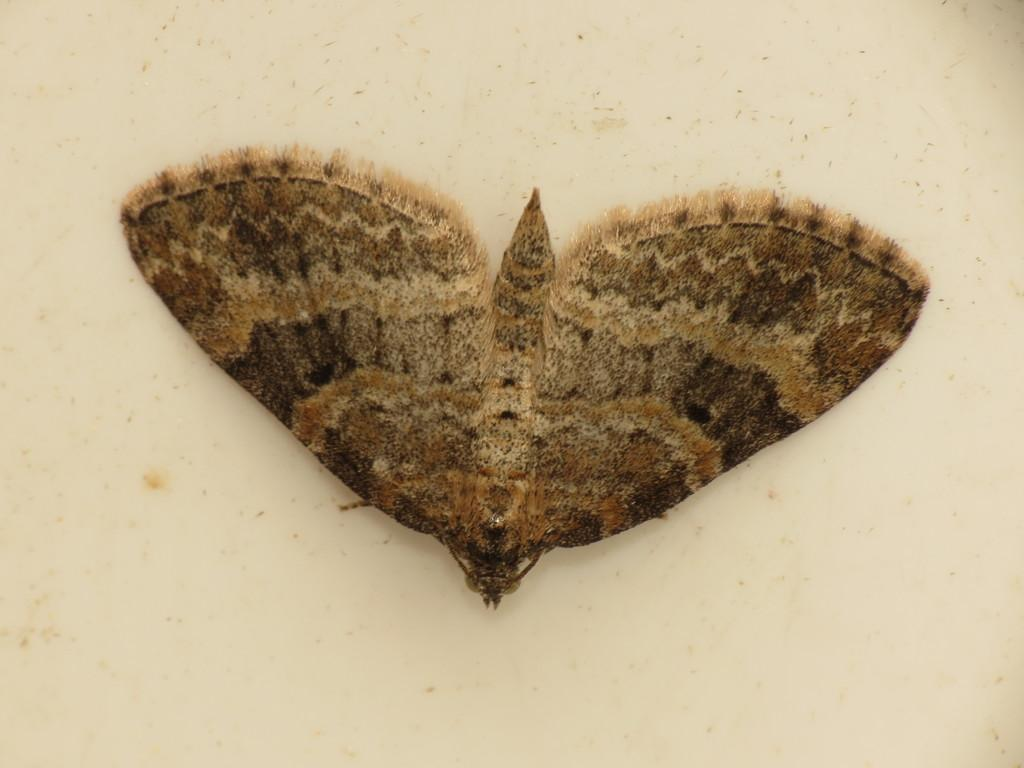What type of insect is present in the image? There is a butterfly in the image. Where is the butterfly located? The butterfly is on a surface. What type of lock is used to secure the butterfly in the image? There is no lock present in the image, as the butterfly is on a surface and not secured. 